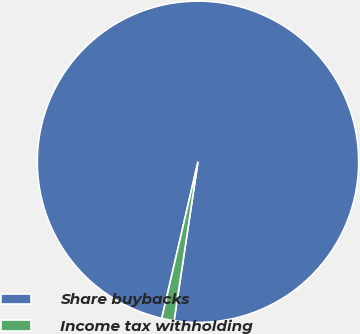Convert chart. <chart><loc_0><loc_0><loc_500><loc_500><pie_chart><fcel>Share buybacks<fcel>Income tax withholding<nl><fcel>98.76%<fcel>1.24%<nl></chart> 